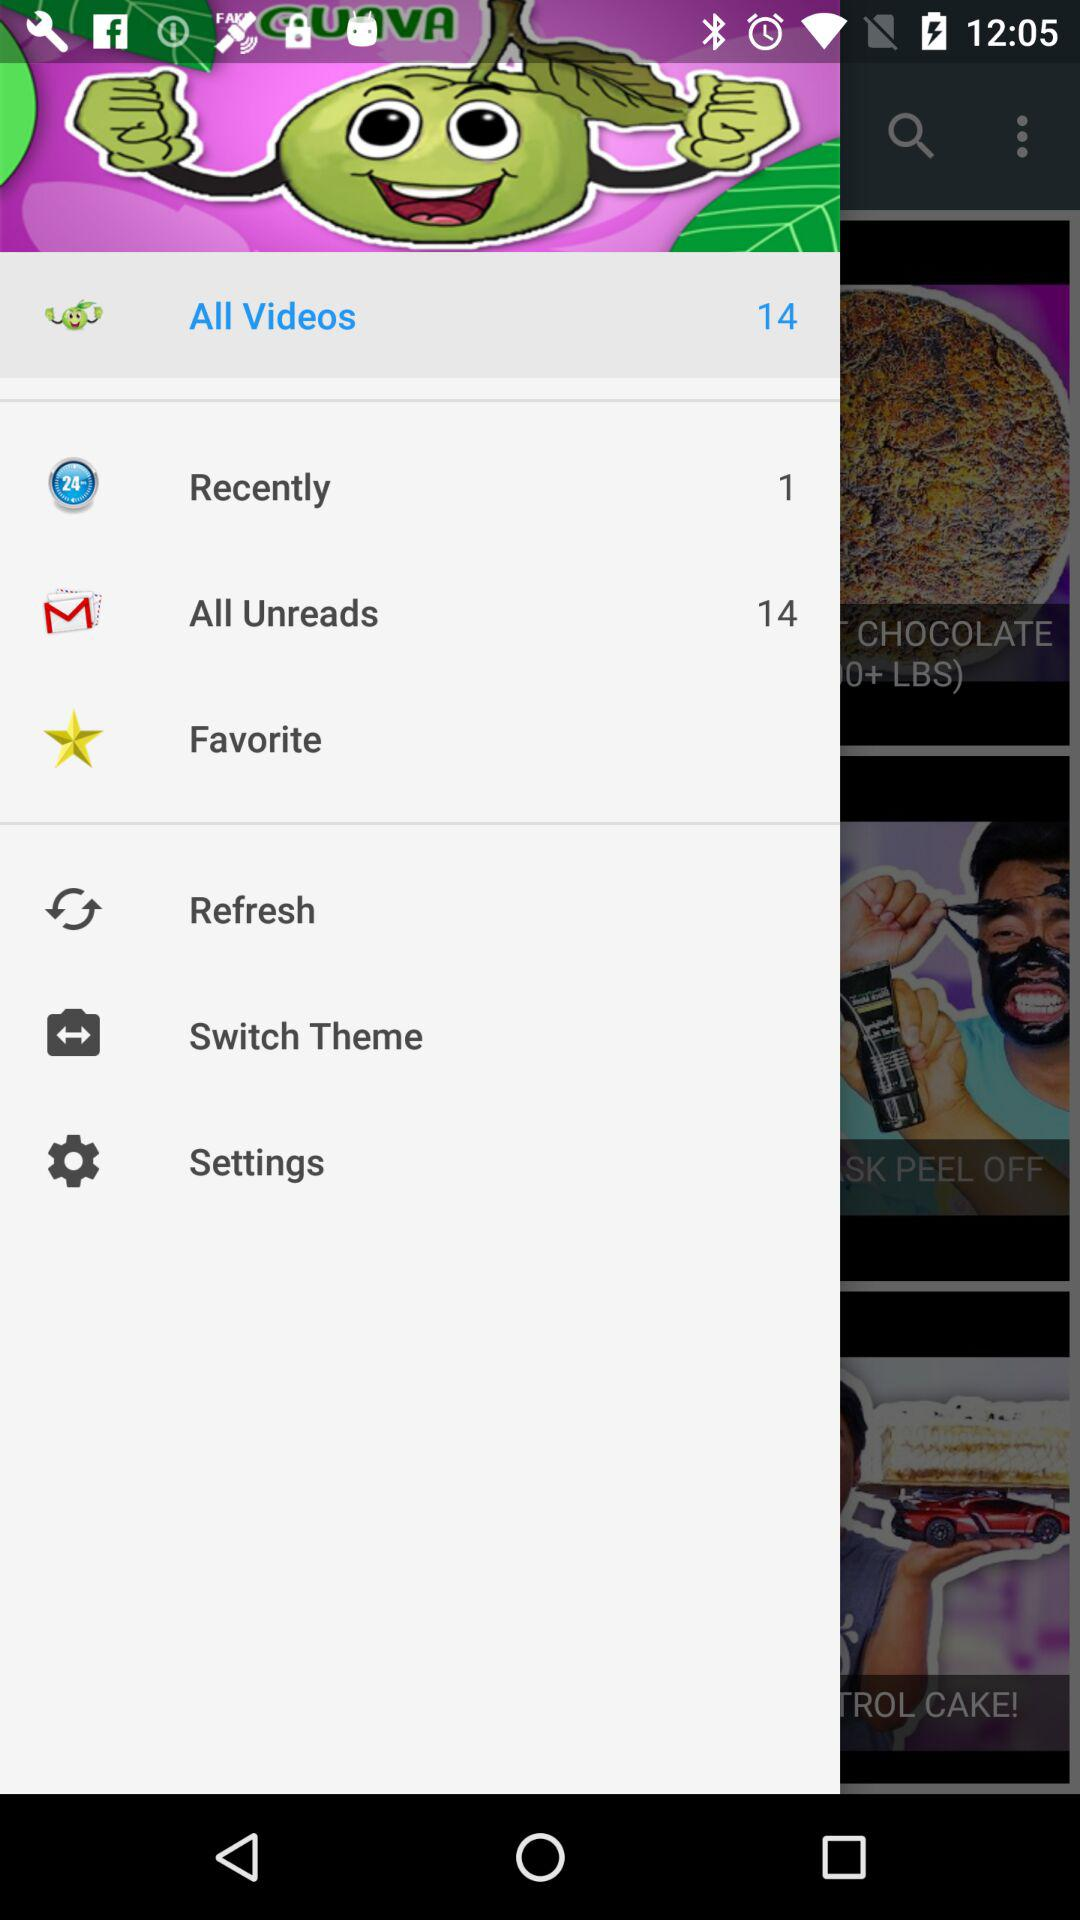How many items are there in "Recently"? There is 1 item in "Recently". 